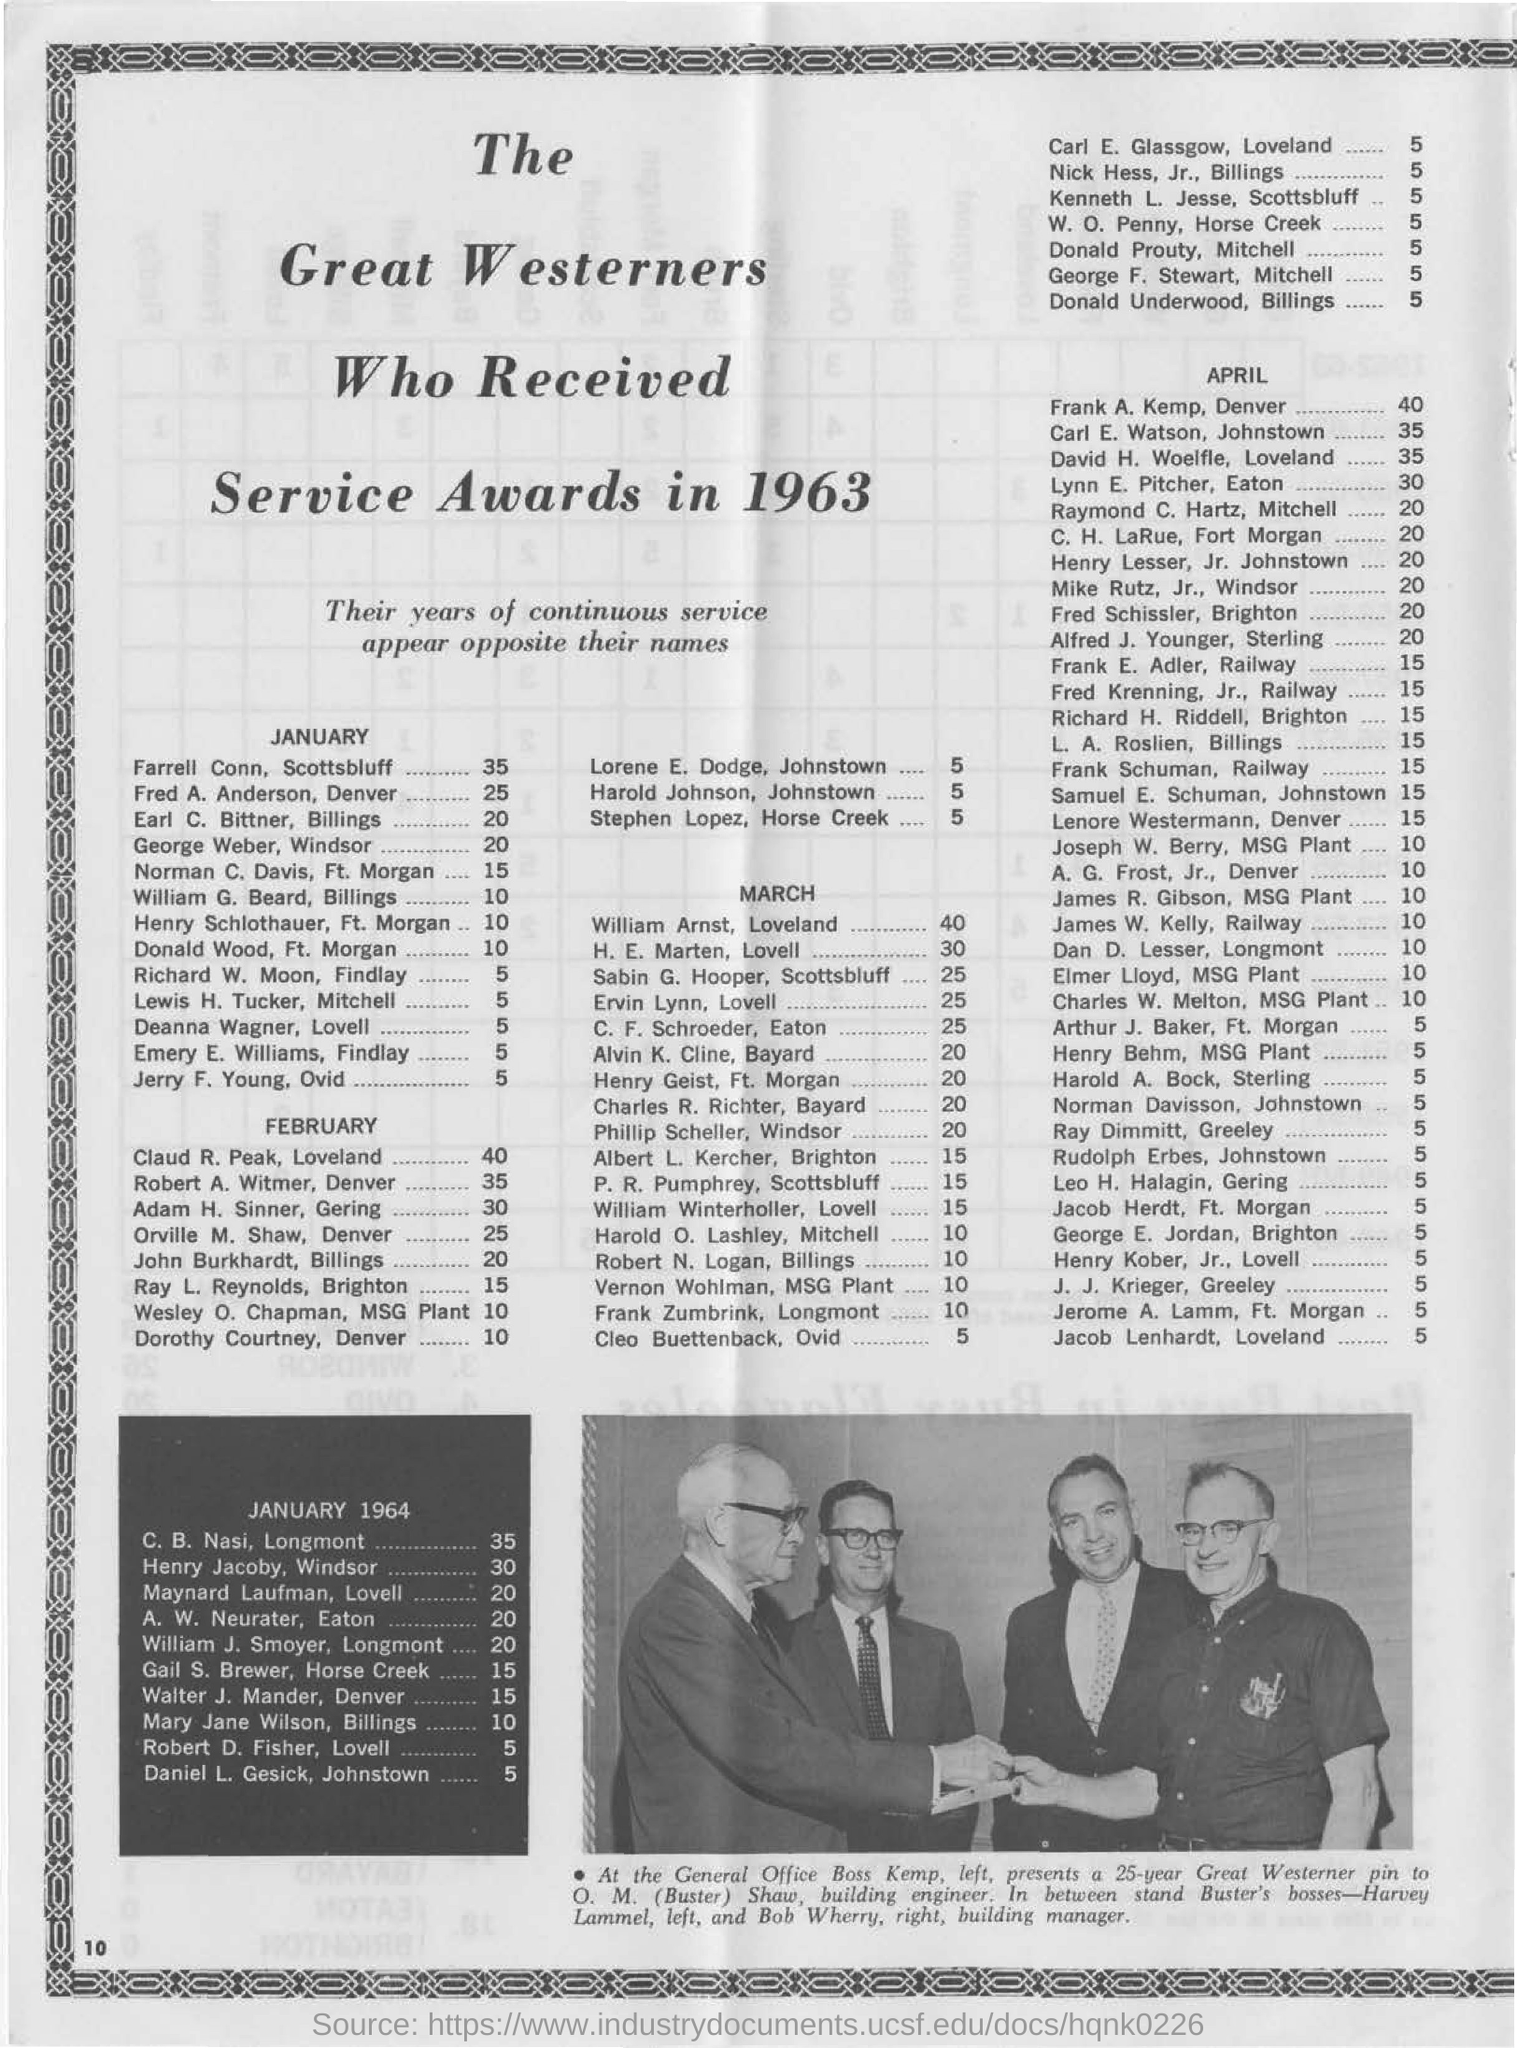How many years of continuous service did farrell conn, scottsbluff achieve?
Give a very brief answer. 35. Which month will farrell conn, scottsbluff achieve 35 years of continuous service?
Provide a succinct answer. January. Which month will claud r. peak, loveland achieve 40 years of continuous service?
Your answer should be compact. FEBRUARY. When were the service awards given to the great westerners in the document?
Give a very brief answer. 1963. 